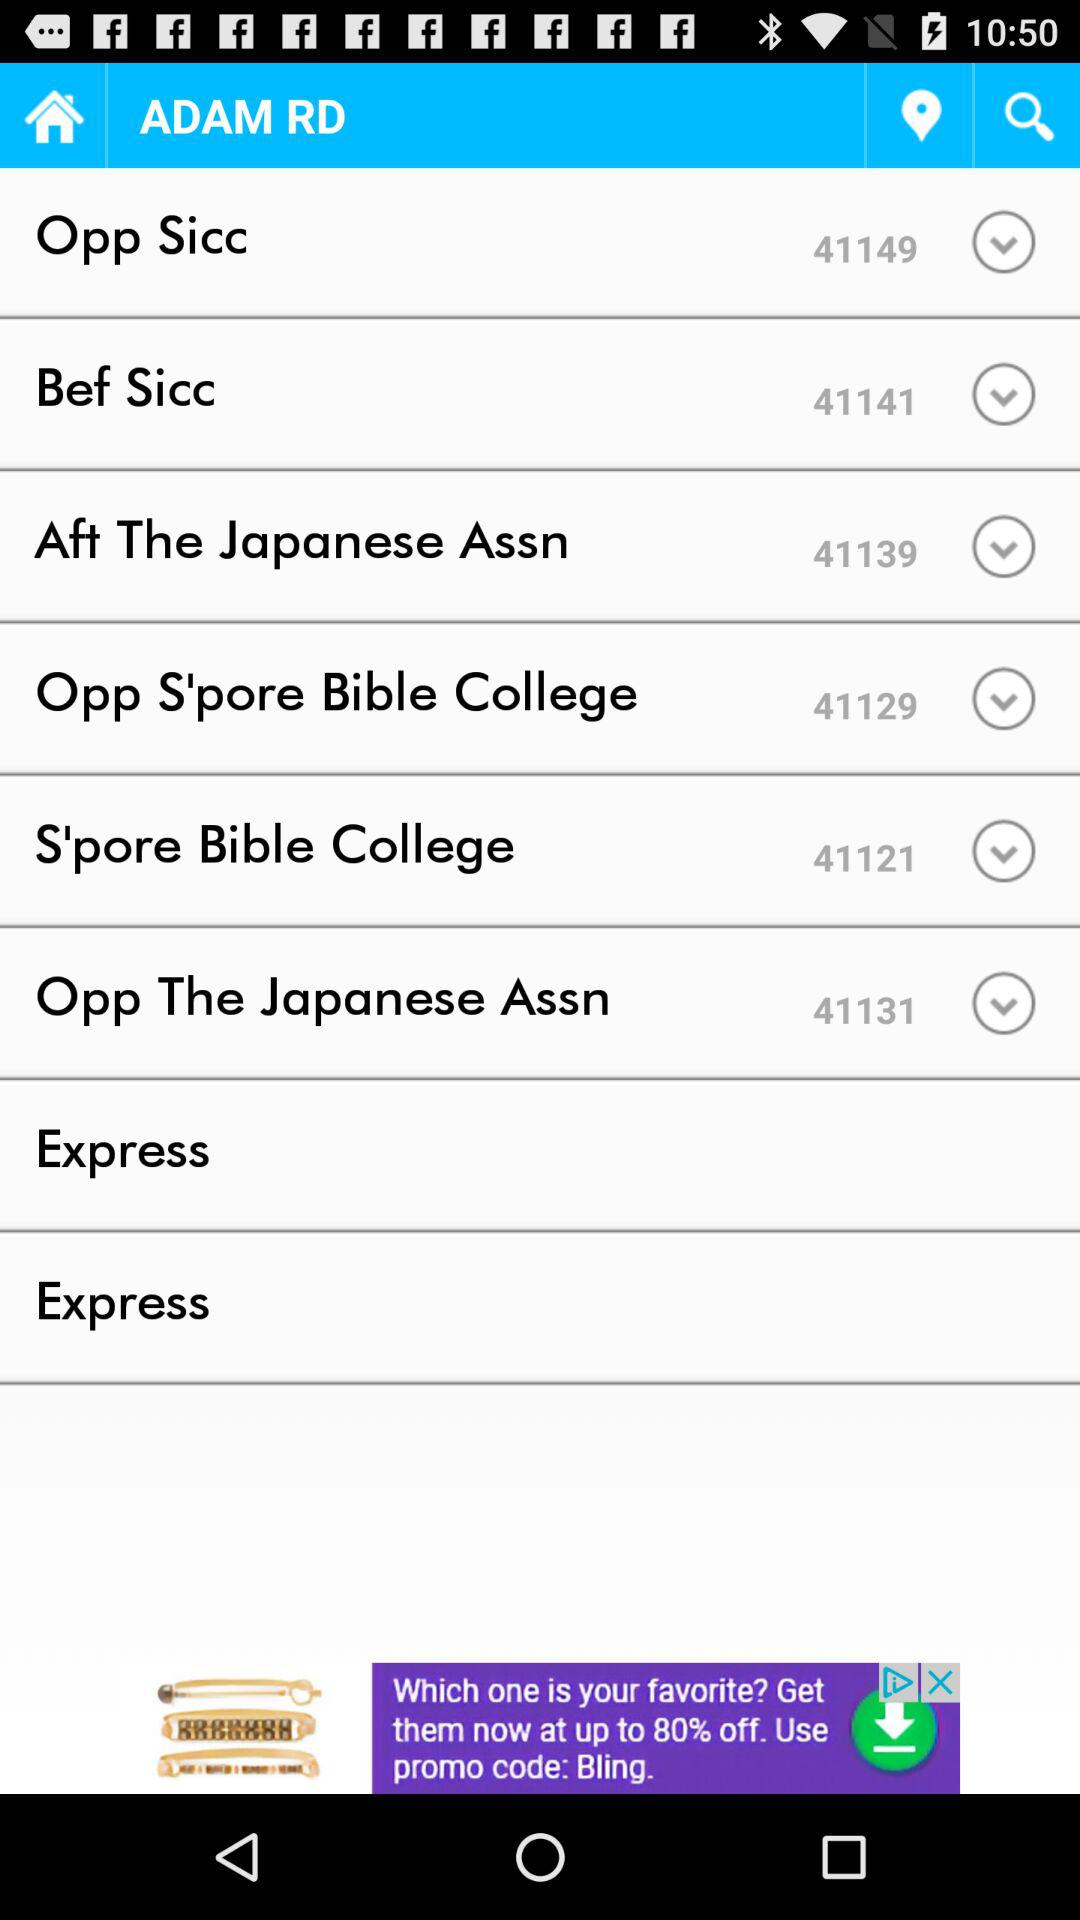What is the "Bef Sicc" bus stop number? The "Bef Sicc" bus stop number is 41141. 